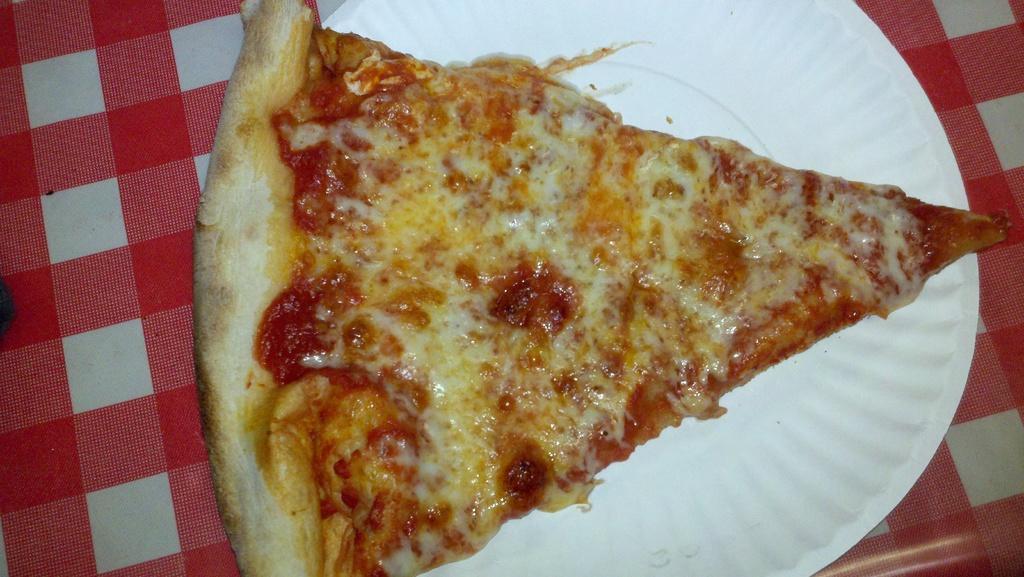In one or two sentences, can you explain what this image depicts? In the center of the image we can see a slice of pizza and a plate placed on the table. 